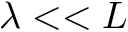Convert formula to latex. <formula><loc_0><loc_0><loc_500><loc_500>\lambda < < L</formula> 